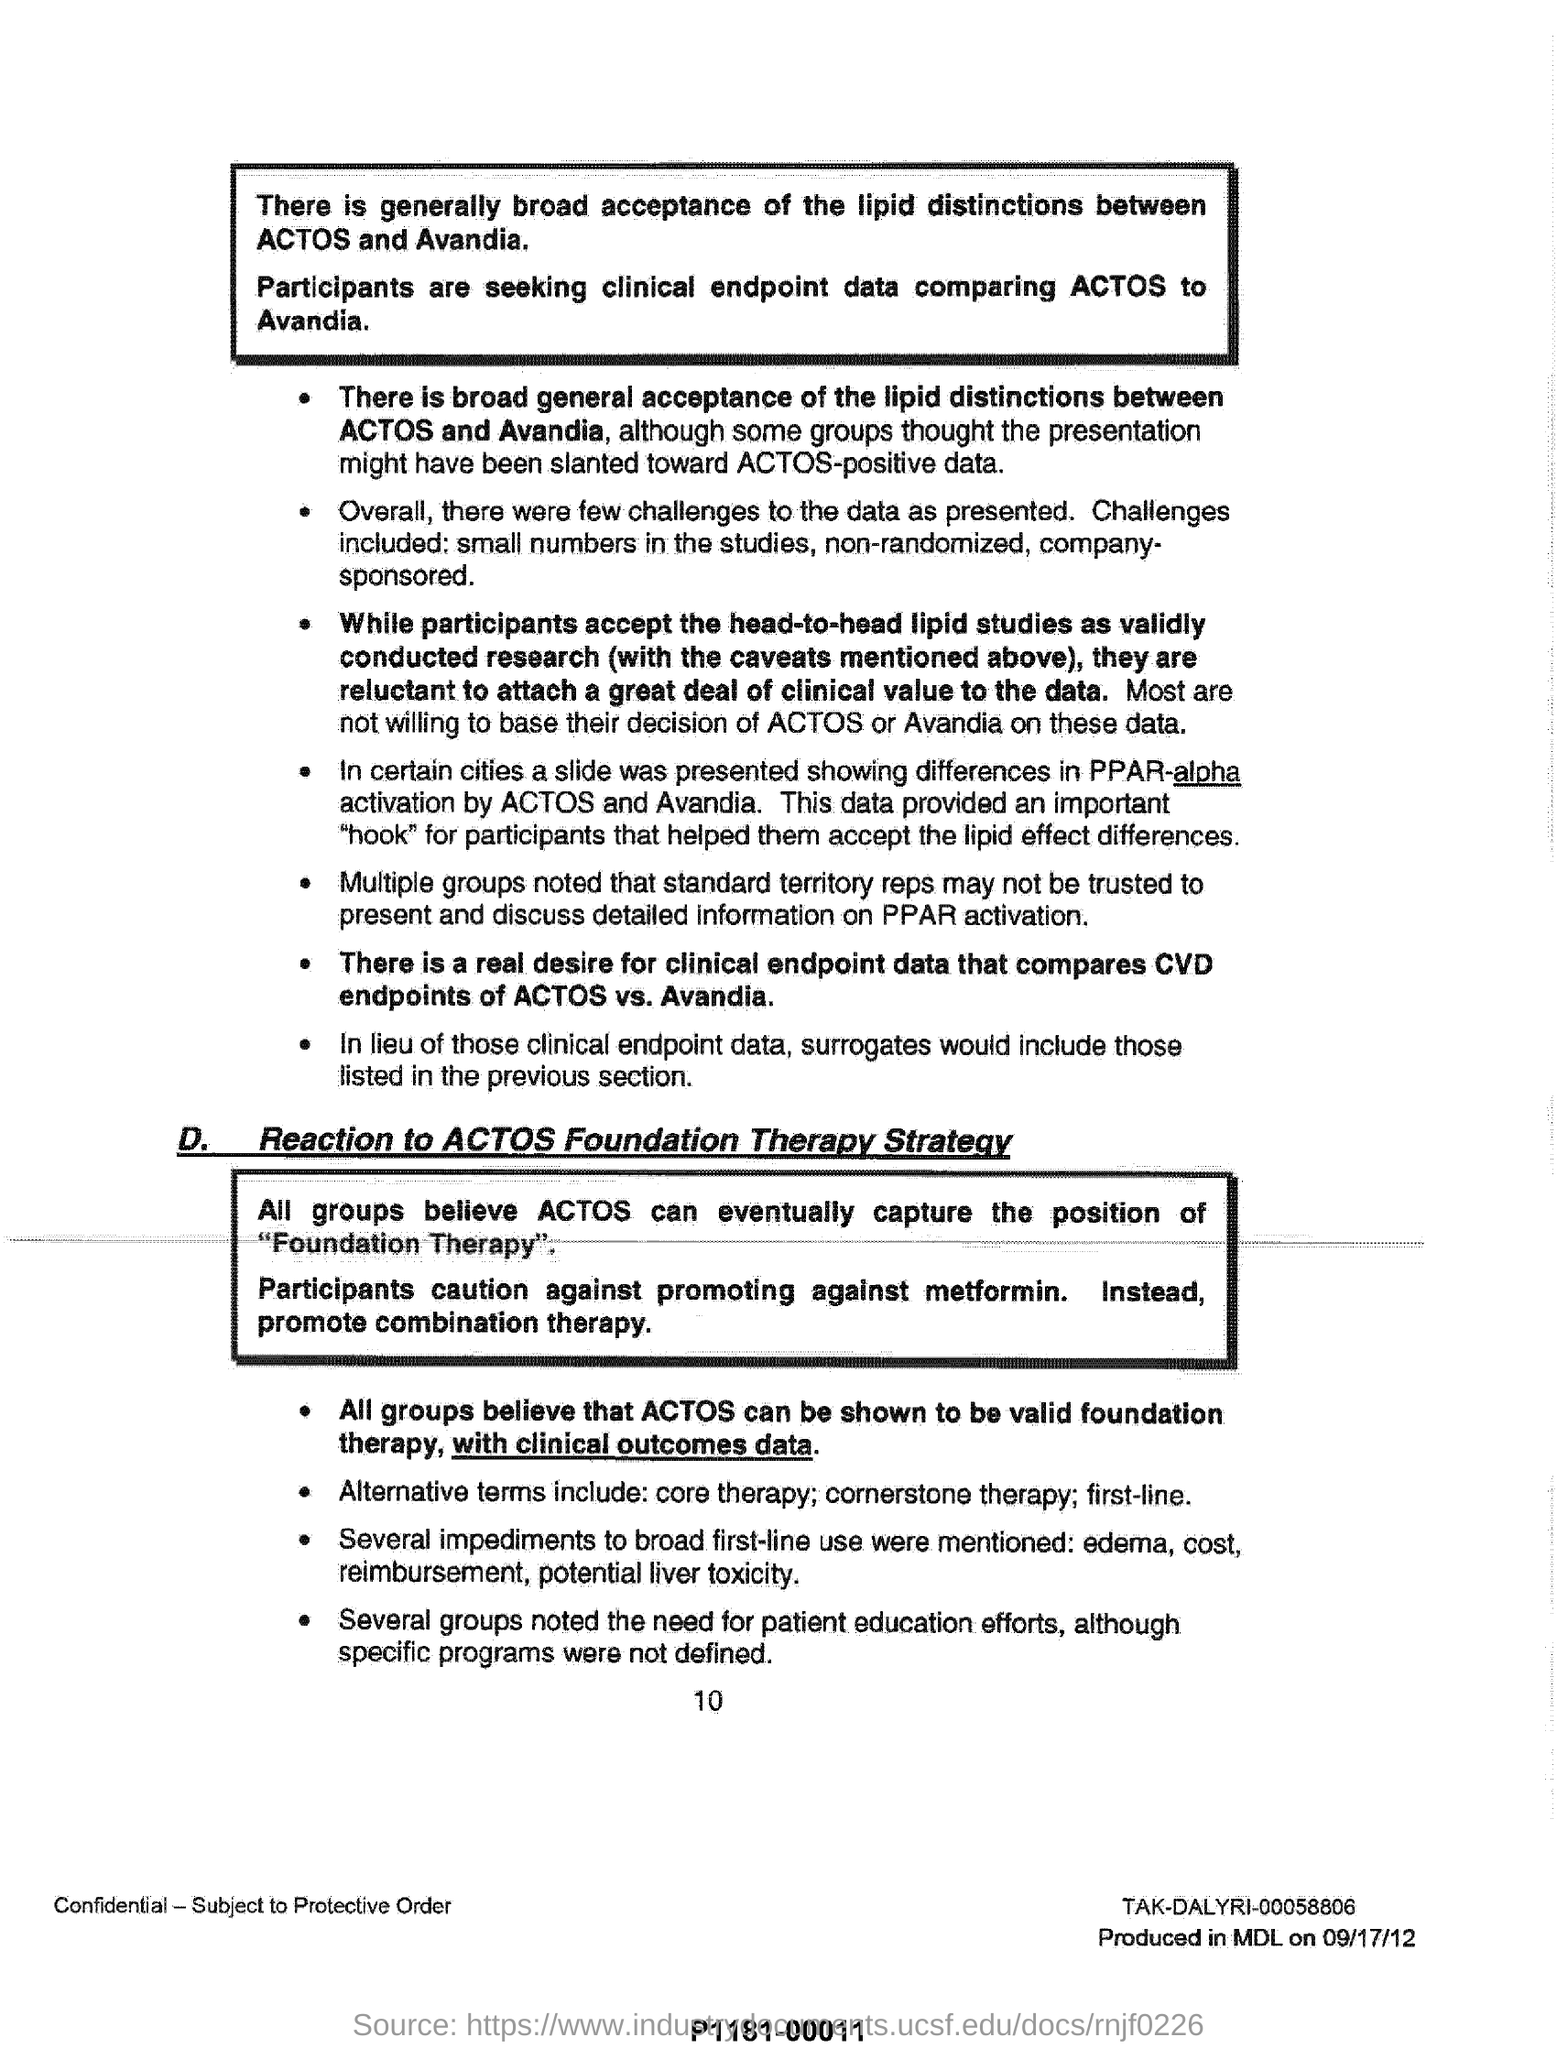What are the challenges of actos positive data?
Ensure brevity in your answer.  Small numbers in the studies, non-randomized, company-sponsored. What does alternate terms include?
Offer a terse response. Core therapy; cornerstone therapy; first-line. 